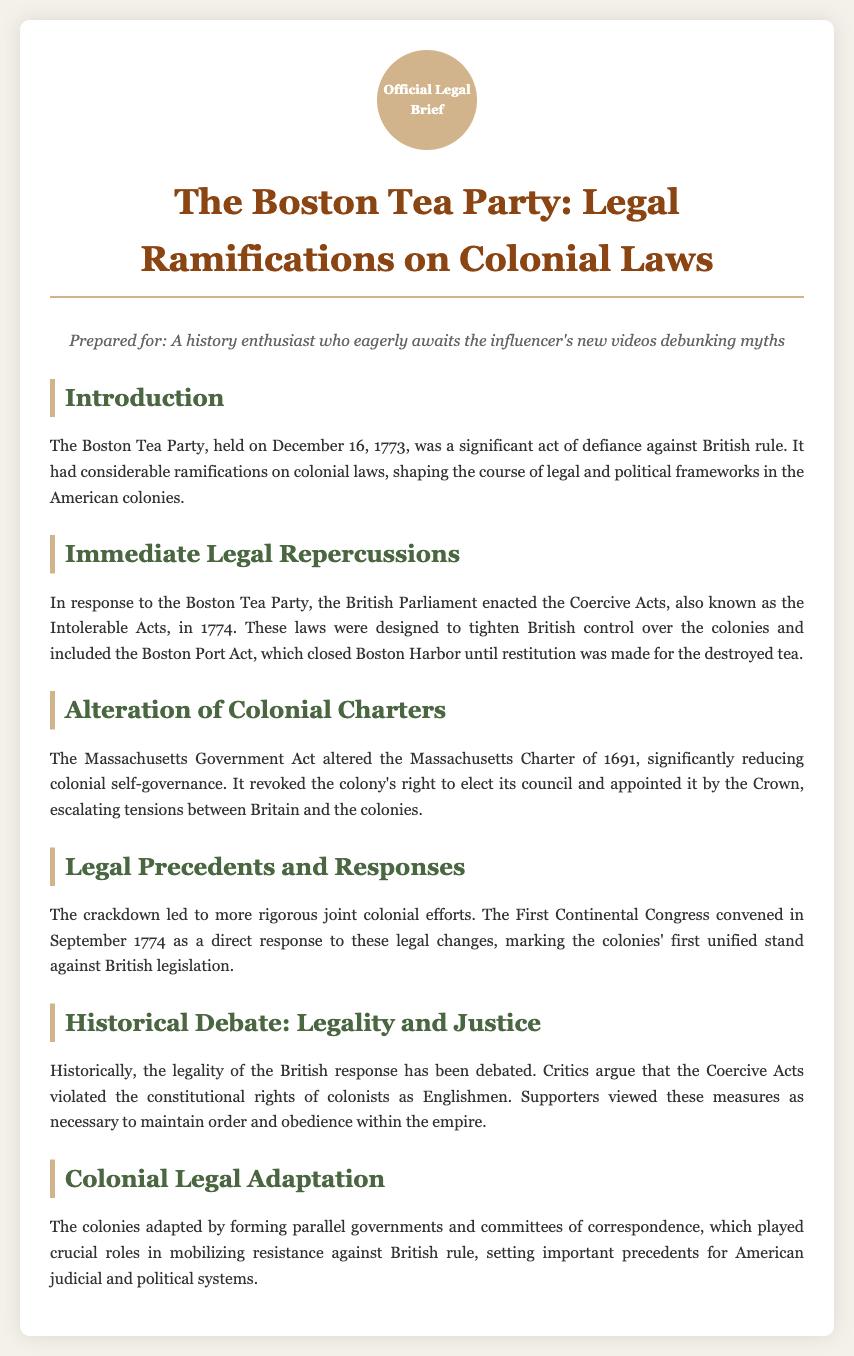What was the date of the Boston Tea Party? The date of the Boston Tea Party is provided in the introduction section of the document.
Answer: December 16, 1773 What act did the British Parliament enact in response to the Boston Tea Party? This information is detailed in the section on Immediate Legal Repercussions.
Answer: Coercive Acts What did the Boston Port Act do? The specific function of the Boston Port Act is described in the Immediate Legal Repercussions section.
Answer: Closed Boston Harbor Which act altered the Massachusetts Charter of 1691? The name of the act that altered the Massachusetts Charter is mentioned in the Alteration of Colonial Charters section.
Answer: Massachusetts Government Act What did the First Continental Congress signify? The significance of the First Continental Congress is addressed in the Legal Precedents and Responses section.
Answer: The colonies' first unified stand What did critics argue regarding the Coercive Acts? This argument is presented in the Historical Debate section discussing differing views on the legality of British actions.
Answer: Violated constitutional rights What was a direct colonial response to British control? The document describes the formation of parallel governments and committees of correspondence as a response in the Colonial Legal Adaptation section.
Answer: Parallel governments What was the primary goal of forming committees of correspondence? The role of these committees is highlighted in the Colonial Legal Adaptation section regarding resistance against British rule.
Answer: Mobilizing resistance 